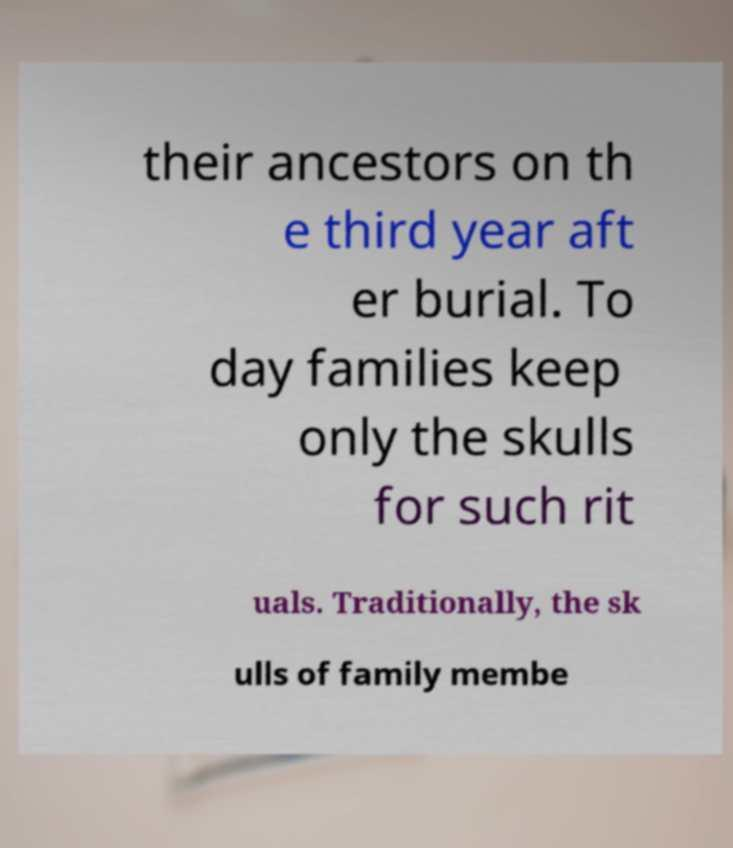For documentation purposes, I need the text within this image transcribed. Could you provide that? their ancestors on th e third year aft er burial. To day families keep only the skulls for such rit uals. Traditionally, the sk ulls of family membe 